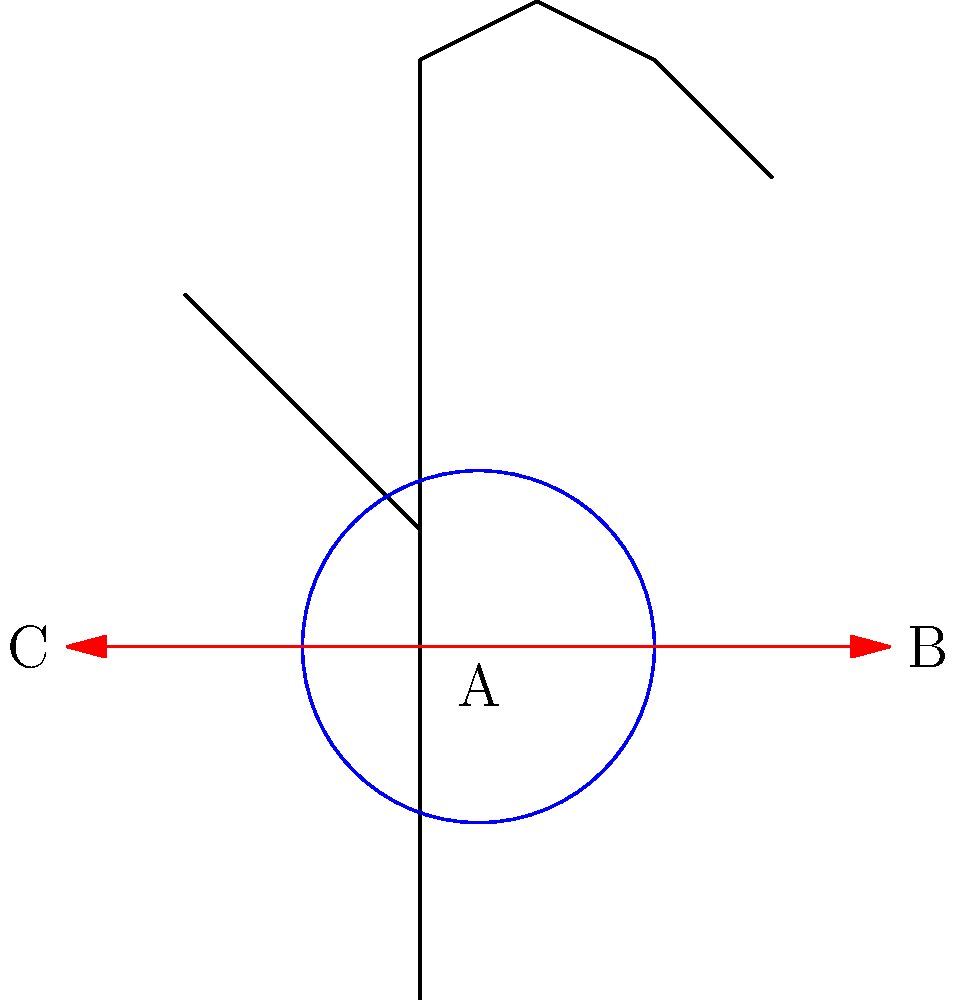In the diagram above, three potential camera grip positions (A, B, and C) are shown for a handheld camera setup. Which grip position is likely to provide the most stable and ergonomic hold for extended periods of filming, and why? To determine the most stable and ergonomic camera grip position, we need to consider several factors:

1. Neutral wrist position: The wrist should be kept as close to neutral as possible to reduce strain.

2. Weight distribution: The camera's weight should be evenly distributed across the hand and forearm.

3. Finger placement: The fingers should be able to comfortably reach controls without excessive stretching.

4. Thumb opposition: The thumb should be able to oppose the fingers for a secure grip.

5. Muscular engagement: The grip should engage larger muscle groups for better endurance.

Analyzing each position:

A. Center grip:
   - Keeps the wrist in a relatively neutral position
   - Allows for even weight distribution
   - Provides good finger placement for camera controls
   - Enables thumb opposition for a secure hold
   - Engages forearm muscles for stability

B. Side grip (right):
   - May cause wrist deviation
   - Uneven weight distribution
   - Potentially awkward finger placement for controls
   - Limited thumb opposition
   - Relies more on smaller hand muscles

C. Side grip (left):
   - Similar issues to position B, but for left-handed users

Based on these considerations, position A (center grip) is likely to provide the most stable and ergonomic hold for extended periods of filming. It allows for a neutral wrist position, even weight distribution, and better engagement of larger muscle groups, which are crucial for reducing fatigue during long shooting sessions.
Answer: Position A (center grip) 